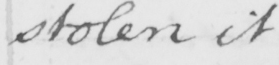Can you read and transcribe this handwriting? stolen it 